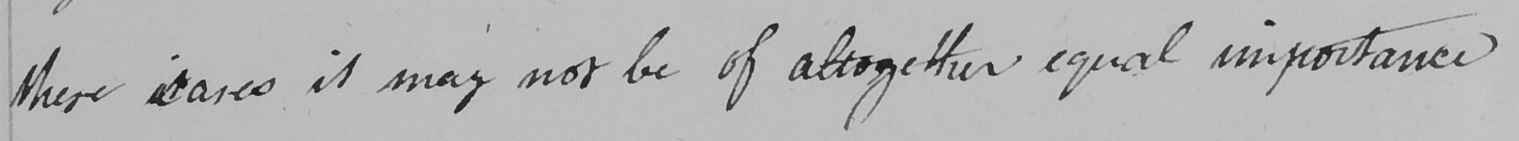Transcribe the text shown in this historical manuscript line. these cases it may not be of altogether equal importance 